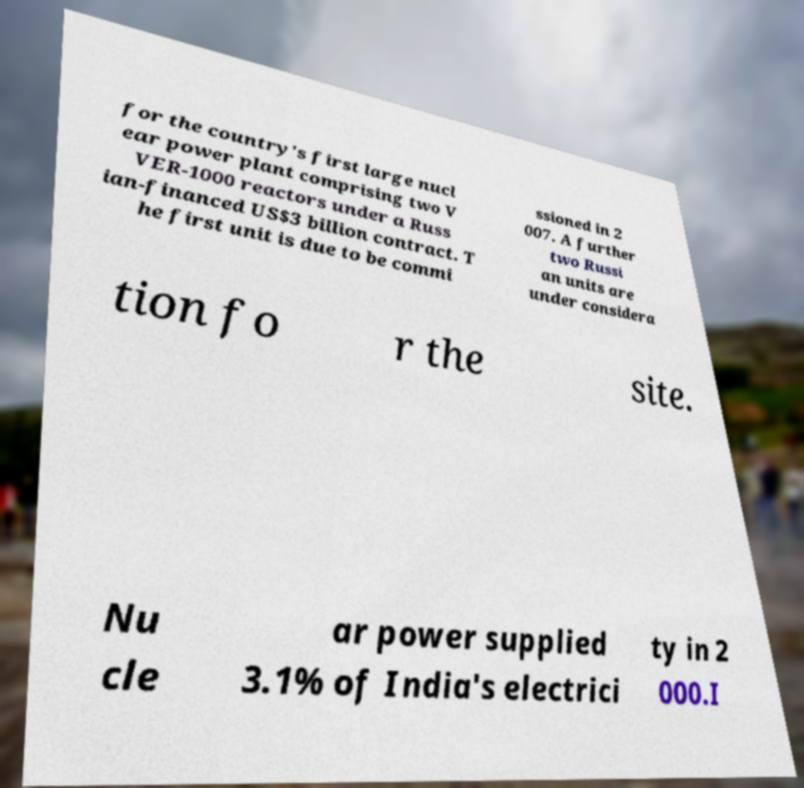What messages or text are displayed in this image? I need them in a readable, typed format. for the country's first large nucl ear power plant comprising two V VER-1000 reactors under a Russ ian-financed US$3 billion contract. T he first unit is due to be commi ssioned in 2 007. A further two Russi an units are under considera tion fo r the site. Nu cle ar power supplied 3.1% of India's electrici ty in 2 000.I 